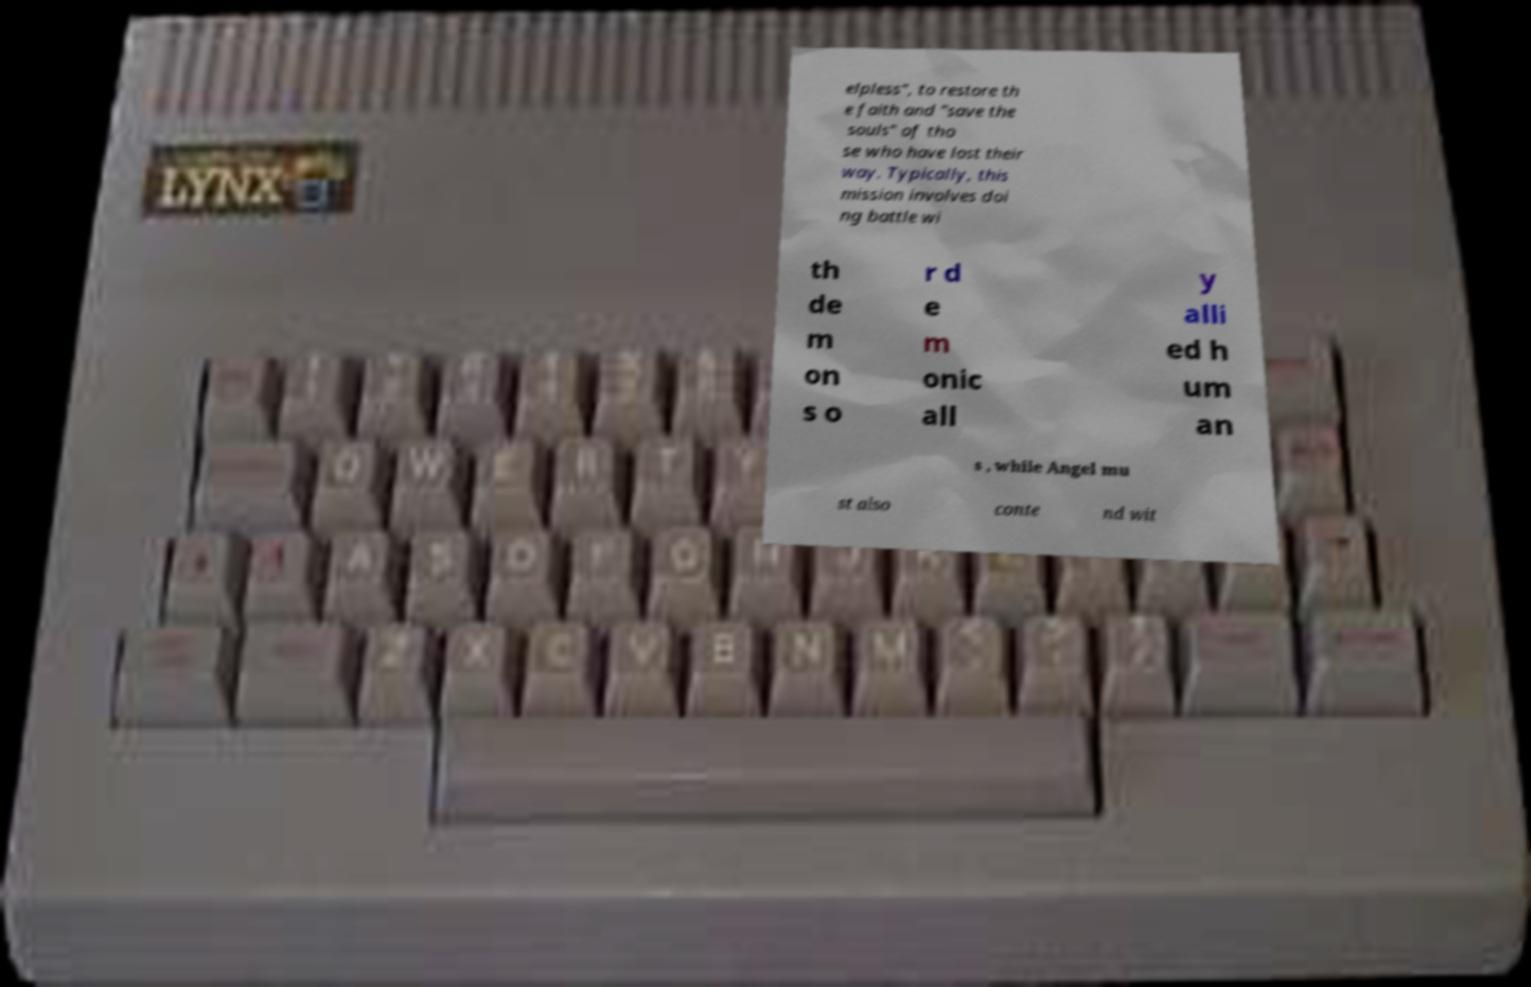Could you assist in decoding the text presented in this image and type it out clearly? elpless", to restore th e faith and "save the souls" of tho se who have lost their way. Typically, this mission involves doi ng battle wi th de m on s o r d e m onic all y alli ed h um an s , while Angel mu st also conte nd wit 